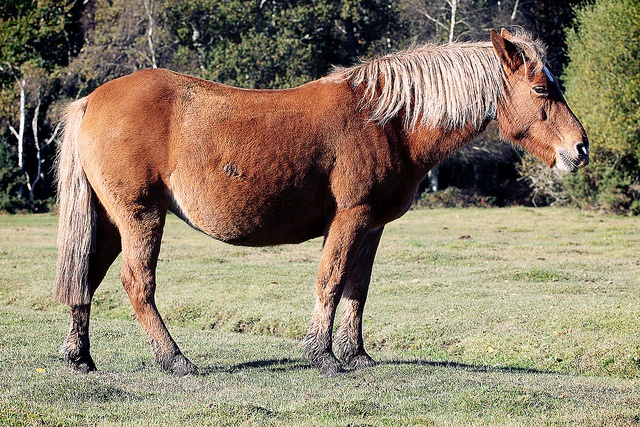Describe the objects in this image and their specific colors. I can see a horse in black, brown, tan, and lightgray tones in this image. 